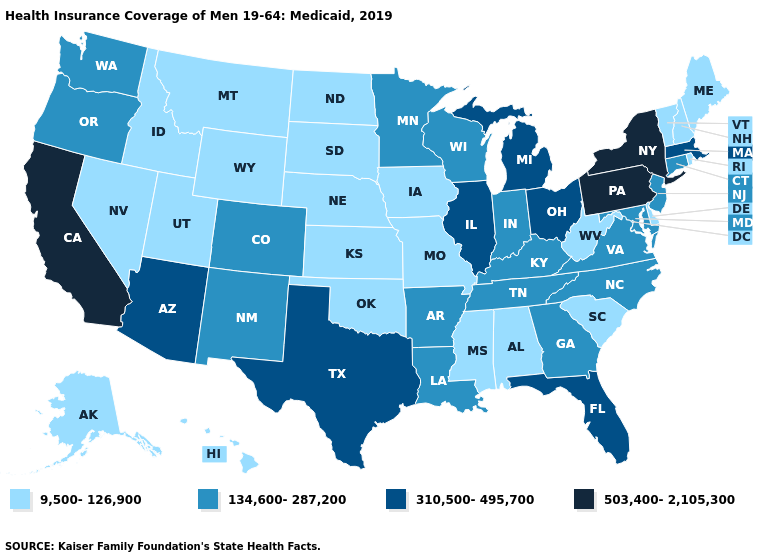Does Tennessee have the highest value in the USA?
Answer briefly. No. Does the first symbol in the legend represent the smallest category?
Write a very short answer. Yes. What is the lowest value in the USA?
Answer briefly. 9,500-126,900. Does the map have missing data?
Keep it brief. No. What is the value of Texas?
Answer briefly. 310,500-495,700. Does North Dakota have the lowest value in the USA?
Be succinct. Yes. What is the value of Mississippi?
Write a very short answer. 9,500-126,900. Does South Dakota have the highest value in the USA?
Concise answer only. No. Does Alabama have the highest value in the South?
Give a very brief answer. No. Does Connecticut have a higher value than Virginia?
Concise answer only. No. Which states have the highest value in the USA?
Give a very brief answer. California, New York, Pennsylvania. Does Illinois have the same value as Washington?
Answer briefly. No. Which states hav the highest value in the West?
Quick response, please. California. What is the value of Mississippi?
Give a very brief answer. 9,500-126,900. Among the states that border Florida , which have the highest value?
Be succinct. Georgia. 